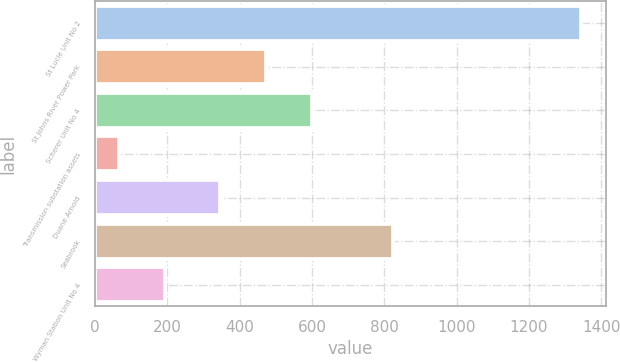Convert chart. <chart><loc_0><loc_0><loc_500><loc_500><bar_chart><fcel>St Lucie Unit No 2<fcel>St Johns River Power Park<fcel>Scherer Unit No 4<fcel>Transmission substation assets<fcel>Duane Arnold<fcel>Seabrook<fcel>Wyman Station Unit No 4<nl><fcel>1345<fcel>472.9<fcel>600.8<fcel>66<fcel>345<fcel>823<fcel>193.9<nl></chart> 